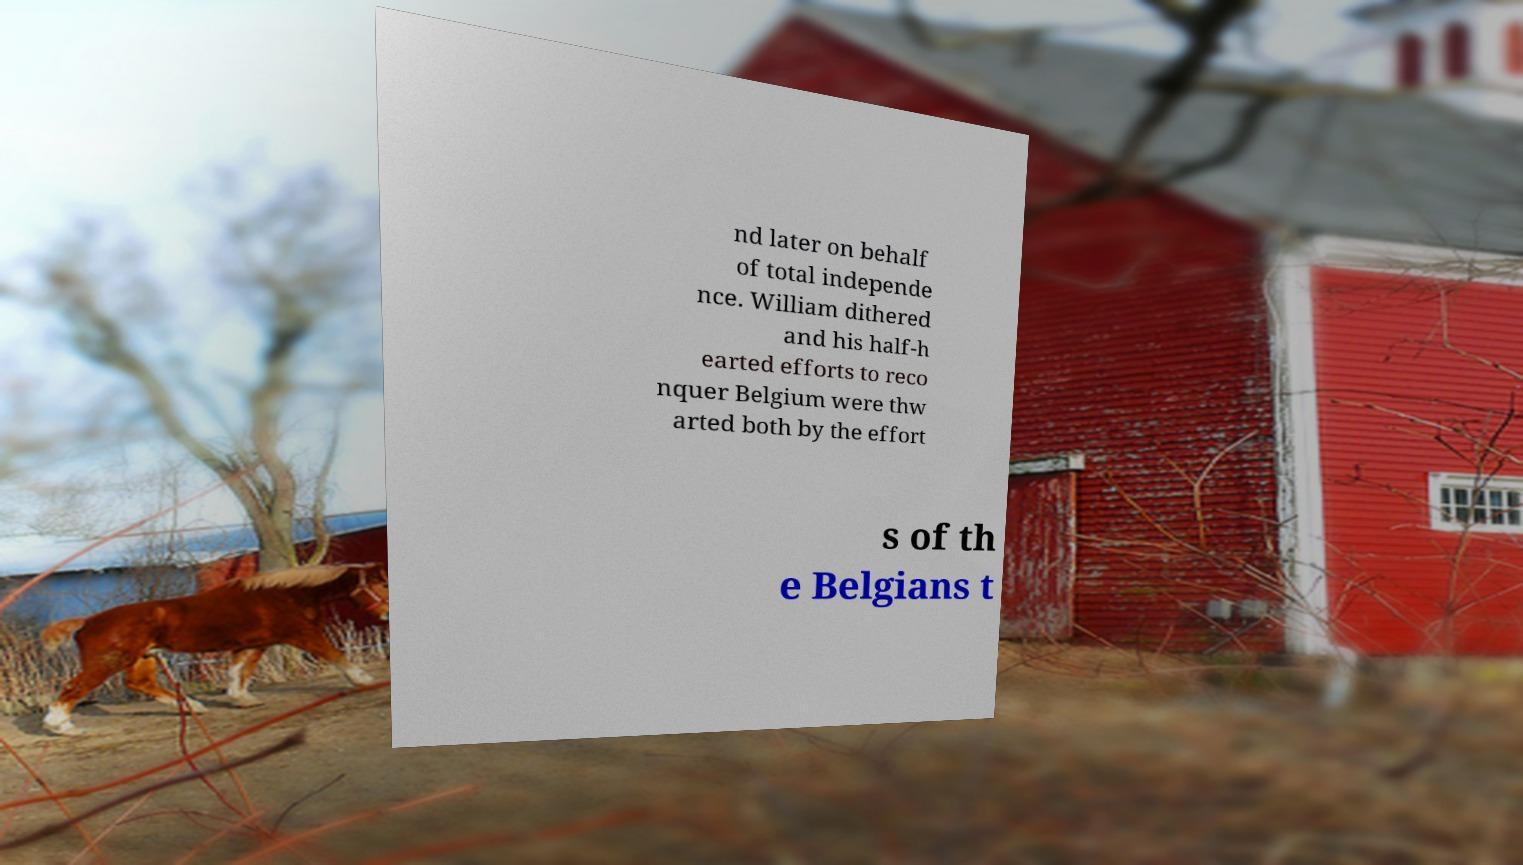What messages or text are displayed in this image? I need them in a readable, typed format. nd later on behalf of total independe nce. William dithered and his half-h earted efforts to reco nquer Belgium were thw arted both by the effort s of th e Belgians t 